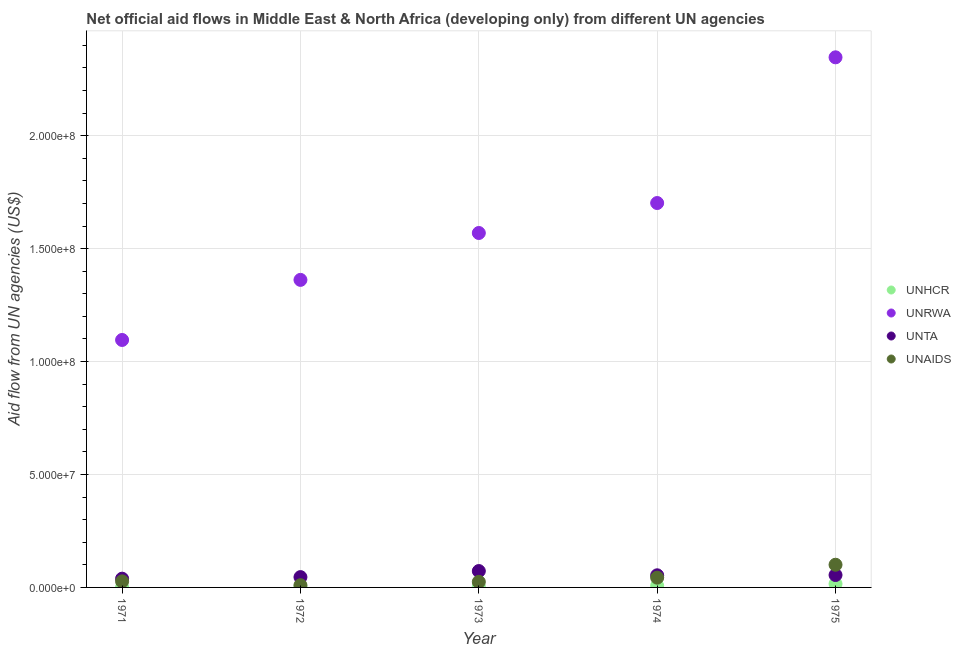How many different coloured dotlines are there?
Keep it short and to the point. 4. What is the amount of aid given by unaids in 1974?
Keep it short and to the point. 4.32e+06. Across all years, what is the maximum amount of aid given by unrwa?
Give a very brief answer. 2.35e+08. Across all years, what is the minimum amount of aid given by unhcr?
Offer a very short reply. 1.30e+05. In which year was the amount of aid given by unta maximum?
Your answer should be compact. 1973. What is the total amount of aid given by unaids in the graph?
Give a very brief answer. 2.05e+07. What is the difference between the amount of aid given by unaids in 1971 and that in 1975?
Offer a very short reply. -7.36e+06. What is the difference between the amount of aid given by unaids in 1974 and the amount of aid given by unhcr in 1973?
Your response must be concise. 3.94e+06. What is the average amount of aid given by unrwa per year?
Provide a succinct answer. 1.62e+08. In the year 1971, what is the difference between the amount of aid given by unaids and amount of aid given by unhcr?
Ensure brevity in your answer.  2.55e+06. In how many years, is the amount of aid given by unta greater than 100000000 US$?
Provide a succinct answer. 0. What is the ratio of the amount of aid given by unrwa in 1974 to that in 1975?
Make the answer very short. 0.73. Is the amount of aid given by unaids in 1971 less than that in 1975?
Provide a succinct answer. Yes. What is the difference between the highest and the second highest amount of aid given by unhcr?
Give a very brief answer. 8.30e+05. What is the difference between the highest and the lowest amount of aid given by unhcr?
Offer a very short reply. 1.45e+06. Is the sum of the amount of aid given by unrwa in 1971 and 1974 greater than the maximum amount of aid given by unaids across all years?
Make the answer very short. Yes. Is it the case that in every year, the sum of the amount of aid given by unta and amount of aid given by unhcr is greater than the sum of amount of aid given by unaids and amount of aid given by unrwa?
Your answer should be compact. Yes. Is it the case that in every year, the sum of the amount of aid given by unhcr and amount of aid given by unrwa is greater than the amount of aid given by unta?
Ensure brevity in your answer.  Yes. Does the amount of aid given by unta monotonically increase over the years?
Make the answer very short. No. Is the amount of aid given by unaids strictly greater than the amount of aid given by unta over the years?
Offer a terse response. No. How many dotlines are there?
Your response must be concise. 4. How many years are there in the graph?
Your answer should be compact. 5. Does the graph contain any zero values?
Provide a short and direct response. No. Does the graph contain grids?
Your answer should be very brief. Yes. Where does the legend appear in the graph?
Keep it short and to the point. Center right. How are the legend labels stacked?
Your answer should be very brief. Vertical. What is the title of the graph?
Offer a very short reply. Net official aid flows in Middle East & North Africa (developing only) from different UN agencies. Does "Third 20% of population" appear as one of the legend labels in the graph?
Provide a succinct answer. No. What is the label or title of the Y-axis?
Give a very brief answer. Aid flow from UN agencies (US$). What is the Aid flow from UN agencies (US$) of UNRWA in 1971?
Offer a terse response. 1.10e+08. What is the Aid flow from UN agencies (US$) in UNTA in 1971?
Provide a succinct answer. 3.88e+06. What is the Aid flow from UN agencies (US$) in UNAIDS in 1971?
Give a very brief answer. 2.68e+06. What is the Aid flow from UN agencies (US$) in UNHCR in 1972?
Offer a terse response. 2.80e+05. What is the Aid flow from UN agencies (US$) of UNRWA in 1972?
Your answer should be compact. 1.36e+08. What is the Aid flow from UN agencies (US$) in UNTA in 1972?
Ensure brevity in your answer.  4.57e+06. What is the Aid flow from UN agencies (US$) of UNAIDS in 1972?
Offer a very short reply. 9.80e+05. What is the Aid flow from UN agencies (US$) of UNRWA in 1973?
Make the answer very short. 1.57e+08. What is the Aid flow from UN agencies (US$) of UNTA in 1973?
Make the answer very short. 7.25e+06. What is the Aid flow from UN agencies (US$) in UNAIDS in 1973?
Ensure brevity in your answer.  2.47e+06. What is the Aid flow from UN agencies (US$) in UNHCR in 1974?
Make the answer very short. 7.50e+05. What is the Aid flow from UN agencies (US$) of UNRWA in 1974?
Ensure brevity in your answer.  1.70e+08. What is the Aid flow from UN agencies (US$) of UNTA in 1974?
Give a very brief answer. 5.37e+06. What is the Aid flow from UN agencies (US$) of UNAIDS in 1974?
Ensure brevity in your answer.  4.32e+06. What is the Aid flow from UN agencies (US$) in UNHCR in 1975?
Your answer should be very brief. 1.58e+06. What is the Aid flow from UN agencies (US$) in UNRWA in 1975?
Your answer should be very brief. 2.35e+08. What is the Aid flow from UN agencies (US$) in UNTA in 1975?
Your response must be concise. 5.49e+06. What is the Aid flow from UN agencies (US$) in UNAIDS in 1975?
Your response must be concise. 1.00e+07. Across all years, what is the maximum Aid flow from UN agencies (US$) in UNHCR?
Offer a terse response. 1.58e+06. Across all years, what is the maximum Aid flow from UN agencies (US$) of UNRWA?
Provide a short and direct response. 2.35e+08. Across all years, what is the maximum Aid flow from UN agencies (US$) of UNTA?
Offer a terse response. 7.25e+06. Across all years, what is the maximum Aid flow from UN agencies (US$) in UNAIDS?
Provide a succinct answer. 1.00e+07. Across all years, what is the minimum Aid flow from UN agencies (US$) of UNHCR?
Offer a terse response. 1.30e+05. Across all years, what is the minimum Aid flow from UN agencies (US$) of UNRWA?
Your response must be concise. 1.10e+08. Across all years, what is the minimum Aid flow from UN agencies (US$) in UNTA?
Keep it short and to the point. 3.88e+06. Across all years, what is the minimum Aid flow from UN agencies (US$) of UNAIDS?
Provide a succinct answer. 9.80e+05. What is the total Aid flow from UN agencies (US$) in UNHCR in the graph?
Provide a short and direct response. 3.12e+06. What is the total Aid flow from UN agencies (US$) in UNRWA in the graph?
Ensure brevity in your answer.  8.08e+08. What is the total Aid flow from UN agencies (US$) in UNTA in the graph?
Your response must be concise. 2.66e+07. What is the total Aid flow from UN agencies (US$) of UNAIDS in the graph?
Ensure brevity in your answer.  2.05e+07. What is the difference between the Aid flow from UN agencies (US$) in UNHCR in 1971 and that in 1972?
Ensure brevity in your answer.  -1.50e+05. What is the difference between the Aid flow from UN agencies (US$) of UNRWA in 1971 and that in 1972?
Ensure brevity in your answer.  -2.66e+07. What is the difference between the Aid flow from UN agencies (US$) in UNTA in 1971 and that in 1972?
Keep it short and to the point. -6.90e+05. What is the difference between the Aid flow from UN agencies (US$) in UNAIDS in 1971 and that in 1972?
Your answer should be compact. 1.70e+06. What is the difference between the Aid flow from UN agencies (US$) of UNRWA in 1971 and that in 1973?
Make the answer very short. -4.74e+07. What is the difference between the Aid flow from UN agencies (US$) of UNTA in 1971 and that in 1973?
Your answer should be very brief. -3.37e+06. What is the difference between the Aid flow from UN agencies (US$) in UNAIDS in 1971 and that in 1973?
Offer a very short reply. 2.10e+05. What is the difference between the Aid flow from UN agencies (US$) in UNHCR in 1971 and that in 1974?
Offer a very short reply. -6.20e+05. What is the difference between the Aid flow from UN agencies (US$) in UNRWA in 1971 and that in 1974?
Give a very brief answer. -6.06e+07. What is the difference between the Aid flow from UN agencies (US$) in UNTA in 1971 and that in 1974?
Give a very brief answer. -1.49e+06. What is the difference between the Aid flow from UN agencies (US$) of UNAIDS in 1971 and that in 1974?
Give a very brief answer. -1.64e+06. What is the difference between the Aid flow from UN agencies (US$) in UNHCR in 1971 and that in 1975?
Your answer should be compact. -1.45e+06. What is the difference between the Aid flow from UN agencies (US$) of UNRWA in 1971 and that in 1975?
Ensure brevity in your answer.  -1.25e+08. What is the difference between the Aid flow from UN agencies (US$) in UNTA in 1971 and that in 1975?
Offer a very short reply. -1.61e+06. What is the difference between the Aid flow from UN agencies (US$) of UNAIDS in 1971 and that in 1975?
Provide a succinct answer. -7.36e+06. What is the difference between the Aid flow from UN agencies (US$) of UNHCR in 1972 and that in 1973?
Your answer should be compact. -1.00e+05. What is the difference between the Aid flow from UN agencies (US$) of UNRWA in 1972 and that in 1973?
Give a very brief answer. -2.08e+07. What is the difference between the Aid flow from UN agencies (US$) of UNTA in 1972 and that in 1973?
Ensure brevity in your answer.  -2.68e+06. What is the difference between the Aid flow from UN agencies (US$) of UNAIDS in 1972 and that in 1973?
Offer a very short reply. -1.49e+06. What is the difference between the Aid flow from UN agencies (US$) of UNHCR in 1972 and that in 1974?
Offer a terse response. -4.70e+05. What is the difference between the Aid flow from UN agencies (US$) in UNRWA in 1972 and that in 1974?
Your answer should be very brief. -3.40e+07. What is the difference between the Aid flow from UN agencies (US$) in UNTA in 1972 and that in 1974?
Keep it short and to the point. -8.00e+05. What is the difference between the Aid flow from UN agencies (US$) in UNAIDS in 1972 and that in 1974?
Give a very brief answer. -3.34e+06. What is the difference between the Aid flow from UN agencies (US$) of UNHCR in 1972 and that in 1975?
Ensure brevity in your answer.  -1.30e+06. What is the difference between the Aid flow from UN agencies (US$) in UNRWA in 1972 and that in 1975?
Ensure brevity in your answer.  -9.85e+07. What is the difference between the Aid flow from UN agencies (US$) in UNTA in 1972 and that in 1975?
Make the answer very short. -9.20e+05. What is the difference between the Aid flow from UN agencies (US$) in UNAIDS in 1972 and that in 1975?
Your answer should be compact. -9.06e+06. What is the difference between the Aid flow from UN agencies (US$) in UNHCR in 1973 and that in 1974?
Keep it short and to the point. -3.70e+05. What is the difference between the Aid flow from UN agencies (US$) of UNRWA in 1973 and that in 1974?
Your answer should be compact. -1.33e+07. What is the difference between the Aid flow from UN agencies (US$) of UNTA in 1973 and that in 1974?
Give a very brief answer. 1.88e+06. What is the difference between the Aid flow from UN agencies (US$) of UNAIDS in 1973 and that in 1974?
Offer a very short reply. -1.85e+06. What is the difference between the Aid flow from UN agencies (US$) in UNHCR in 1973 and that in 1975?
Offer a very short reply. -1.20e+06. What is the difference between the Aid flow from UN agencies (US$) of UNRWA in 1973 and that in 1975?
Offer a very short reply. -7.78e+07. What is the difference between the Aid flow from UN agencies (US$) in UNTA in 1973 and that in 1975?
Your answer should be compact. 1.76e+06. What is the difference between the Aid flow from UN agencies (US$) in UNAIDS in 1973 and that in 1975?
Your response must be concise. -7.57e+06. What is the difference between the Aid flow from UN agencies (US$) of UNHCR in 1974 and that in 1975?
Offer a terse response. -8.30e+05. What is the difference between the Aid flow from UN agencies (US$) in UNRWA in 1974 and that in 1975?
Ensure brevity in your answer.  -6.45e+07. What is the difference between the Aid flow from UN agencies (US$) in UNAIDS in 1974 and that in 1975?
Make the answer very short. -5.72e+06. What is the difference between the Aid flow from UN agencies (US$) of UNHCR in 1971 and the Aid flow from UN agencies (US$) of UNRWA in 1972?
Provide a short and direct response. -1.36e+08. What is the difference between the Aid flow from UN agencies (US$) of UNHCR in 1971 and the Aid flow from UN agencies (US$) of UNTA in 1972?
Ensure brevity in your answer.  -4.44e+06. What is the difference between the Aid flow from UN agencies (US$) of UNHCR in 1971 and the Aid flow from UN agencies (US$) of UNAIDS in 1972?
Keep it short and to the point. -8.50e+05. What is the difference between the Aid flow from UN agencies (US$) of UNRWA in 1971 and the Aid flow from UN agencies (US$) of UNTA in 1972?
Offer a very short reply. 1.05e+08. What is the difference between the Aid flow from UN agencies (US$) of UNRWA in 1971 and the Aid flow from UN agencies (US$) of UNAIDS in 1972?
Your response must be concise. 1.09e+08. What is the difference between the Aid flow from UN agencies (US$) of UNTA in 1971 and the Aid flow from UN agencies (US$) of UNAIDS in 1972?
Your answer should be very brief. 2.90e+06. What is the difference between the Aid flow from UN agencies (US$) of UNHCR in 1971 and the Aid flow from UN agencies (US$) of UNRWA in 1973?
Your answer should be compact. -1.57e+08. What is the difference between the Aid flow from UN agencies (US$) of UNHCR in 1971 and the Aid flow from UN agencies (US$) of UNTA in 1973?
Keep it short and to the point. -7.12e+06. What is the difference between the Aid flow from UN agencies (US$) in UNHCR in 1971 and the Aid flow from UN agencies (US$) in UNAIDS in 1973?
Offer a terse response. -2.34e+06. What is the difference between the Aid flow from UN agencies (US$) in UNRWA in 1971 and the Aid flow from UN agencies (US$) in UNTA in 1973?
Offer a terse response. 1.02e+08. What is the difference between the Aid flow from UN agencies (US$) in UNRWA in 1971 and the Aid flow from UN agencies (US$) in UNAIDS in 1973?
Ensure brevity in your answer.  1.07e+08. What is the difference between the Aid flow from UN agencies (US$) in UNTA in 1971 and the Aid flow from UN agencies (US$) in UNAIDS in 1973?
Offer a very short reply. 1.41e+06. What is the difference between the Aid flow from UN agencies (US$) of UNHCR in 1971 and the Aid flow from UN agencies (US$) of UNRWA in 1974?
Your response must be concise. -1.70e+08. What is the difference between the Aid flow from UN agencies (US$) of UNHCR in 1971 and the Aid flow from UN agencies (US$) of UNTA in 1974?
Make the answer very short. -5.24e+06. What is the difference between the Aid flow from UN agencies (US$) in UNHCR in 1971 and the Aid flow from UN agencies (US$) in UNAIDS in 1974?
Make the answer very short. -4.19e+06. What is the difference between the Aid flow from UN agencies (US$) of UNRWA in 1971 and the Aid flow from UN agencies (US$) of UNTA in 1974?
Your answer should be compact. 1.04e+08. What is the difference between the Aid flow from UN agencies (US$) in UNRWA in 1971 and the Aid flow from UN agencies (US$) in UNAIDS in 1974?
Keep it short and to the point. 1.05e+08. What is the difference between the Aid flow from UN agencies (US$) in UNTA in 1971 and the Aid flow from UN agencies (US$) in UNAIDS in 1974?
Provide a short and direct response. -4.40e+05. What is the difference between the Aid flow from UN agencies (US$) of UNHCR in 1971 and the Aid flow from UN agencies (US$) of UNRWA in 1975?
Give a very brief answer. -2.35e+08. What is the difference between the Aid flow from UN agencies (US$) of UNHCR in 1971 and the Aid flow from UN agencies (US$) of UNTA in 1975?
Your response must be concise. -5.36e+06. What is the difference between the Aid flow from UN agencies (US$) in UNHCR in 1971 and the Aid flow from UN agencies (US$) in UNAIDS in 1975?
Your answer should be very brief. -9.91e+06. What is the difference between the Aid flow from UN agencies (US$) in UNRWA in 1971 and the Aid flow from UN agencies (US$) in UNTA in 1975?
Offer a very short reply. 1.04e+08. What is the difference between the Aid flow from UN agencies (US$) of UNRWA in 1971 and the Aid flow from UN agencies (US$) of UNAIDS in 1975?
Your answer should be very brief. 9.95e+07. What is the difference between the Aid flow from UN agencies (US$) in UNTA in 1971 and the Aid flow from UN agencies (US$) in UNAIDS in 1975?
Provide a short and direct response. -6.16e+06. What is the difference between the Aid flow from UN agencies (US$) of UNHCR in 1972 and the Aid flow from UN agencies (US$) of UNRWA in 1973?
Ensure brevity in your answer.  -1.57e+08. What is the difference between the Aid flow from UN agencies (US$) in UNHCR in 1972 and the Aid flow from UN agencies (US$) in UNTA in 1973?
Your response must be concise. -6.97e+06. What is the difference between the Aid flow from UN agencies (US$) in UNHCR in 1972 and the Aid flow from UN agencies (US$) in UNAIDS in 1973?
Your response must be concise. -2.19e+06. What is the difference between the Aid flow from UN agencies (US$) in UNRWA in 1972 and the Aid flow from UN agencies (US$) in UNTA in 1973?
Provide a short and direct response. 1.29e+08. What is the difference between the Aid flow from UN agencies (US$) of UNRWA in 1972 and the Aid flow from UN agencies (US$) of UNAIDS in 1973?
Your response must be concise. 1.34e+08. What is the difference between the Aid flow from UN agencies (US$) of UNTA in 1972 and the Aid flow from UN agencies (US$) of UNAIDS in 1973?
Your response must be concise. 2.10e+06. What is the difference between the Aid flow from UN agencies (US$) of UNHCR in 1972 and the Aid flow from UN agencies (US$) of UNRWA in 1974?
Offer a terse response. -1.70e+08. What is the difference between the Aid flow from UN agencies (US$) of UNHCR in 1972 and the Aid flow from UN agencies (US$) of UNTA in 1974?
Make the answer very short. -5.09e+06. What is the difference between the Aid flow from UN agencies (US$) of UNHCR in 1972 and the Aid flow from UN agencies (US$) of UNAIDS in 1974?
Offer a terse response. -4.04e+06. What is the difference between the Aid flow from UN agencies (US$) of UNRWA in 1972 and the Aid flow from UN agencies (US$) of UNTA in 1974?
Provide a succinct answer. 1.31e+08. What is the difference between the Aid flow from UN agencies (US$) in UNRWA in 1972 and the Aid flow from UN agencies (US$) in UNAIDS in 1974?
Your answer should be compact. 1.32e+08. What is the difference between the Aid flow from UN agencies (US$) of UNHCR in 1972 and the Aid flow from UN agencies (US$) of UNRWA in 1975?
Give a very brief answer. -2.34e+08. What is the difference between the Aid flow from UN agencies (US$) in UNHCR in 1972 and the Aid flow from UN agencies (US$) in UNTA in 1975?
Ensure brevity in your answer.  -5.21e+06. What is the difference between the Aid flow from UN agencies (US$) of UNHCR in 1972 and the Aid flow from UN agencies (US$) of UNAIDS in 1975?
Your response must be concise. -9.76e+06. What is the difference between the Aid flow from UN agencies (US$) of UNRWA in 1972 and the Aid flow from UN agencies (US$) of UNTA in 1975?
Keep it short and to the point. 1.31e+08. What is the difference between the Aid flow from UN agencies (US$) of UNRWA in 1972 and the Aid flow from UN agencies (US$) of UNAIDS in 1975?
Ensure brevity in your answer.  1.26e+08. What is the difference between the Aid flow from UN agencies (US$) of UNTA in 1972 and the Aid flow from UN agencies (US$) of UNAIDS in 1975?
Make the answer very short. -5.47e+06. What is the difference between the Aid flow from UN agencies (US$) in UNHCR in 1973 and the Aid flow from UN agencies (US$) in UNRWA in 1974?
Give a very brief answer. -1.70e+08. What is the difference between the Aid flow from UN agencies (US$) in UNHCR in 1973 and the Aid flow from UN agencies (US$) in UNTA in 1974?
Give a very brief answer. -4.99e+06. What is the difference between the Aid flow from UN agencies (US$) in UNHCR in 1973 and the Aid flow from UN agencies (US$) in UNAIDS in 1974?
Offer a terse response. -3.94e+06. What is the difference between the Aid flow from UN agencies (US$) in UNRWA in 1973 and the Aid flow from UN agencies (US$) in UNTA in 1974?
Provide a short and direct response. 1.52e+08. What is the difference between the Aid flow from UN agencies (US$) of UNRWA in 1973 and the Aid flow from UN agencies (US$) of UNAIDS in 1974?
Your answer should be compact. 1.53e+08. What is the difference between the Aid flow from UN agencies (US$) in UNTA in 1973 and the Aid flow from UN agencies (US$) in UNAIDS in 1974?
Keep it short and to the point. 2.93e+06. What is the difference between the Aid flow from UN agencies (US$) of UNHCR in 1973 and the Aid flow from UN agencies (US$) of UNRWA in 1975?
Provide a short and direct response. -2.34e+08. What is the difference between the Aid flow from UN agencies (US$) of UNHCR in 1973 and the Aid flow from UN agencies (US$) of UNTA in 1975?
Keep it short and to the point. -5.11e+06. What is the difference between the Aid flow from UN agencies (US$) of UNHCR in 1973 and the Aid flow from UN agencies (US$) of UNAIDS in 1975?
Give a very brief answer. -9.66e+06. What is the difference between the Aid flow from UN agencies (US$) of UNRWA in 1973 and the Aid flow from UN agencies (US$) of UNTA in 1975?
Keep it short and to the point. 1.51e+08. What is the difference between the Aid flow from UN agencies (US$) of UNRWA in 1973 and the Aid flow from UN agencies (US$) of UNAIDS in 1975?
Provide a short and direct response. 1.47e+08. What is the difference between the Aid flow from UN agencies (US$) in UNTA in 1973 and the Aid flow from UN agencies (US$) in UNAIDS in 1975?
Make the answer very short. -2.79e+06. What is the difference between the Aid flow from UN agencies (US$) of UNHCR in 1974 and the Aid flow from UN agencies (US$) of UNRWA in 1975?
Provide a short and direct response. -2.34e+08. What is the difference between the Aid flow from UN agencies (US$) in UNHCR in 1974 and the Aid flow from UN agencies (US$) in UNTA in 1975?
Make the answer very short. -4.74e+06. What is the difference between the Aid flow from UN agencies (US$) in UNHCR in 1974 and the Aid flow from UN agencies (US$) in UNAIDS in 1975?
Offer a terse response. -9.29e+06. What is the difference between the Aid flow from UN agencies (US$) of UNRWA in 1974 and the Aid flow from UN agencies (US$) of UNTA in 1975?
Your answer should be compact. 1.65e+08. What is the difference between the Aid flow from UN agencies (US$) of UNRWA in 1974 and the Aid flow from UN agencies (US$) of UNAIDS in 1975?
Your response must be concise. 1.60e+08. What is the difference between the Aid flow from UN agencies (US$) of UNTA in 1974 and the Aid flow from UN agencies (US$) of UNAIDS in 1975?
Make the answer very short. -4.67e+06. What is the average Aid flow from UN agencies (US$) in UNHCR per year?
Provide a short and direct response. 6.24e+05. What is the average Aid flow from UN agencies (US$) in UNRWA per year?
Provide a succinct answer. 1.62e+08. What is the average Aid flow from UN agencies (US$) of UNTA per year?
Your response must be concise. 5.31e+06. What is the average Aid flow from UN agencies (US$) of UNAIDS per year?
Provide a short and direct response. 4.10e+06. In the year 1971, what is the difference between the Aid flow from UN agencies (US$) of UNHCR and Aid flow from UN agencies (US$) of UNRWA?
Your response must be concise. -1.09e+08. In the year 1971, what is the difference between the Aid flow from UN agencies (US$) in UNHCR and Aid flow from UN agencies (US$) in UNTA?
Give a very brief answer. -3.75e+06. In the year 1971, what is the difference between the Aid flow from UN agencies (US$) of UNHCR and Aid flow from UN agencies (US$) of UNAIDS?
Make the answer very short. -2.55e+06. In the year 1971, what is the difference between the Aid flow from UN agencies (US$) of UNRWA and Aid flow from UN agencies (US$) of UNTA?
Your answer should be very brief. 1.06e+08. In the year 1971, what is the difference between the Aid flow from UN agencies (US$) of UNRWA and Aid flow from UN agencies (US$) of UNAIDS?
Keep it short and to the point. 1.07e+08. In the year 1971, what is the difference between the Aid flow from UN agencies (US$) of UNTA and Aid flow from UN agencies (US$) of UNAIDS?
Offer a very short reply. 1.20e+06. In the year 1972, what is the difference between the Aid flow from UN agencies (US$) of UNHCR and Aid flow from UN agencies (US$) of UNRWA?
Keep it short and to the point. -1.36e+08. In the year 1972, what is the difference between the Aid flow from UN agencies (US$) in UNHCR and Aid flow from UN agencies (US$) in UNTA?
Your answer should be very brief. -4.29e+06. In the year 1972, what is the difference between the Aid flow from UN agencies (US$) in UNHCR and Aid flow from UN agencies (US$) in UNAIDS?
Keep it short and to the point. -7.00e+05. In the year 1972, what is the difference between the Aid flow from UN agencies (US$) of UNRWA and Aid flow from UN agencies (US$) of UNTA?
Give a very brief answer. 1.32e+08. In the year 1972, what is the difference between the Aid flow from UN agencies (US$) of UNRWA and Aid flow from UN agencies (US$) of UNAIDS?
Provide a short and direct response. 1.35e+08. In the year 1972, what is the difference between the Aid flow from UN agencies (US$) in UNTA and Aid flow from UN agencies (US$) in UNAIDS?
Make the answer very short. 3.59e+06. In the year 1973, what is the difference between the Aid flow from UN agencies (US$) of UNHCR and Aid flow from UN agencies (US$) of UNRWA?
Offer a very short reply. -1.57e+08. In the year 1973, what is the difference between the Aid flow from UN agencies (US$) in UNHCR and Aid flow from UN agencies (US$) in UNTA?
Give a very brief answer. -6.87e+06. In the year 1973, what is the difference between the Aid flow from UN agencies (US$) in UNHCR and Aid flow from UN agencies (US$) in UNAIDS?
Offer a terse response. -2.09e+06. In the year 1973, what is the difference between the Aid flow from UN agencies (US$) in UNRWA and Aid flow from UN agencies (US$) in UNTA?
Keep it short and to the point. 1.50e+08. In the year 1973, what is the difference between the Aid flow from UN agencies (US$) of UNRWA and Aid flow from UN agencies (US$) of UNAIDS?
Provide a succinct answer. 1.54e+08. In the year 1973, what is the difference between the Aid flow from UN agencies (US$) of UNTA and Aid flow from UN agencies (US$) of UNAIDS?
Ensure brevity in your answer.  4.78e+06. In the year 1974, what is the difference between the Aid flow from UN agencies (US$) in UNHCR and Aid flow from UN agencies (US$) in UNRWA?
Your response must be concise. -1.69e+08. In the year 1974, what is the difference between the Aid flow from UN agencies (US$) of UNHCR and Aid flow from UN agencies (US$) of UNTA?
Ensure brevity in your answer.  -4.62e+06. In the year 1974, what is the difference between the Aid flow from UN agencies (US$) in UNHCR and Aid flow from UN agencies (US$) in UNAIDS?
Give a very brief answer. -3.57e+06. In the year 1974, what is the difference between the Aid flow from UN agencies (US$) in UNRWA and Aid flow from UN agencies (US$) in UNTA?
Provide a succinct answer. 1.65e+08. In the year 1974, what is the difference between the Aid flow from UN agencies (US$) of UNRWA and Aid flow from UN agencies (US$) of UNAIDS?
Give a very brief answer. 1.66e+08. In the year 1974, what is the difference between the Aid flow from UN agencies (US$) in UNTA and Aid flow from UN agencies (US$) in UNAIDS?
Your answer should be very brief. 1.05e+06. In the year 1975, what is the difference between the Aid flow from UN agencies (US$) of UNHCR and Aid flow from UN agencies (US$) of UNRWA?
Your response must be concise. -2.33e+08. In the year 1975, what is the difference between the Aid flow from UN agencies (US$) of UNHCR and Aid flow from UN agencies (US$) of UNTA?
Your response must be concise. -3.91e+06. In the year 1975, what is the difference between the Aid flow from UN agencies (US$) in UNHCR and Aid flow from UN agencies (US$) in UNAIDS?
Offer a very short reply. -8.46e+06. In the year 1975, what is the difference between the Aid flow from UN agencies (US$) of UNRWA and Aid flow from UN agencies (US$) of UNTA?
Your answer should be compact. 2.29e+08. In the year 1975, what is the difference between the Aid flow from UN agencies (US$) of UNRWA and Aid flow from UN agencies (US$) of UNAIDS?
Make the answer very short. 2.25e+08. In the year 1975, what is the difference between the Aid flow from UN agencies (US$) in UNTA and Aid flow from UN agencies (US$) in UNAIDS?
Your answer should be compact. -4.55e+06. What is the ratio of the Aid flow from UN agencies (US$) in UNHCR in 1971 to that in 1972?
Offer a terse response. 0.46. What is the ratio of the Aid flow from UN agencies (US$) of UNRWA in 1971 to that in 1972?
Your response must be concise. 0.8. What is the ratio of the Aid flow from UN agencies (US$) of UNTA in 1971 to that in 1972?
Make the answer very short. 0.85. What is the ratio of the Aid flow from UN agencies (US$) of UNAIDS in 1971 to that in 1972?
Ensure brevity in your answer.  2.73. What is the ratio of the Aid flow from UN agencies (US$) of UNHCR in 1971 to that in 1973?
Provide a short and direct response. 0.34. What is the ratio of the Aid flow from UN agencies (US$) of UNRWA in 1971 to that in 1973?
Offer a very short reply. 0.7. What is the ratio of the Aid flow from UN agencies (US$) in UNTA in 1971 to that in 1973?
Offer a terse response. 0.54. What is the ratio of the Aid flow from UN agencies (US$) of UNAIDS in 1971 to that in 1973?
Offer a terse response. 1.08. What is the ratio of the Aid flow from UN agencies (US$) of UNHCR in 1971 to that in 1974?
Your answer should be compact. 0.17. What is the ratio of the Aid flow from UN agencies (US$) of UNRWA in 1971 to that in 1974?
Give a very brief answer. 0.64. What is the ratio of the Aid flow from UN agencies (US$) in UNTA in 1971 to that in 1974?
Offer a very short reply. 0.72. What is the ratio of the Aid flow from UN agencies (US$) of UNAIDS in 1971 to that in 1974?
Give a very brief answer. 0.62. What is the ratio of the Aid flow from UN agencies (US$) of UNHCR in 1971 to that in 1975?
Give a very brief answer. 0.08. What is the ratio of the Aid flow from UN agencies (US$) in UNRWA in 1971 to that in 1975?
Provide a short and direct response. 0.47. What is the ratio of the Aid flow from UN agencies (US$) of UNTA in 1971 to that in 1975?
Make the answer very short. 0.71. What is the ratio of the Aid flow from UN agencies (US$) of UNAIDS in 1971 to that in 1975?
Offer a terse response. 0.27. What is the ratio of the Aid flow from UN agencies (US$) in UNHCR in 1972 to that in 1973?
Provide a succinct answer. 0.74. What is the ratio of the Aid flow from UN agencies (US$) in UNRWA in 1972 to that in 1973?
Provide a short and direct response. 0.87. What is the ratio of the Aid flow from UN agencies (US$) of UNTA in 1972 to that in 1973?
Ensure brevity in your answer.  0.63. What is the ratio of the Aid flow from UN agencies (US$) of UNAIDS in 1972 to that in 1973?
Keep it short and to the point. 0.4. What is the ratio of the Aid flow from UN agencies (US$) in UNHCR in 1972 to that in 1974?
Offer a terse response. 0.37. What is the ratio of the Aid flow from UN agencies (US$) in UNRWA in 1972 to that in 1974?
Provide a short and direct response. 0.8. What is the ratio of the Aid flow from UN agencies (US$) of UNTA in 1972 to that in 1974?
Your response must be concise. 0.85. What is the ratio of the Aid flow from UN agencies (US$) in UNAIDS in 1972 to that in 1974?
Keep it short and to the point. 0.23. What is the ratio of the Aid flow from UN agencies (US$) in UNHCR in 1972 to that in 1975?
Ensure brevity in your answer.  0.18. What is the ratio of the Aid flow from UN agencies (US$) in UNRWA in 1972 to that in 1975?
Give a very brief answer. 0.58. What is the ratio of the Aid flow from UN agencies (US$) of UNTA in 1972 to that in 1975?
Make the answer very short. 0.83. What is the ratio of the Aid flow from UN agencies (US$) in UNAIDS in 1972 to that in 1975?
Your answer should be very brief. 0.1. What is the ratio of the Aid flow from UN agencies (US$) in UNHCR in 1973 to that in 1974?
Provide a short and direct response. 0.51. What is the ratio of the Aid flow from UN agencies (US$) in UNRWA in 1973 to that in 1974?
Ensure brevity in your answer.  0.92. What is the ratio of the Aid flow from UN agencies (US$) in UNTA in 1973 to that in 1974?
Ensure brevity in your answer.  1.35. What is the ratio of the Aid flow from UN agencies (US$) of UNAIDS in 1973 to that in 1974?
Keep it short and to the point. 0.57. What is the ratio of the Aid flow from UN agencies (US$) of UNHCR in 1973 to that in 1975?
Offer a very short reply. 0.24. What is the ratio of the Aid flow from UN agencies (US$) in UNRWA in 1973 to that in 1975?
Make the answer very short. 0.67. What is the ratio of the Aid flow from UN agencies (US$) in UNTA in 1973 to that in 1975?
Your answer should be very brief. 1.32. What is the ratio of the Aid flow from UN agencies (US$) in UNAIDS in 1973 to that in 1975?
Offer a very short reply. 0.25. What is the ratio of the Aid flow from UN agencies (US$) in UNHCR in 1974 to that in 1975?
Your answer should be very brief. 0.47. What is the ratio of the Aid flow from UN agencies (US$) of UNRWA in 1974 to that in 1975?
Your answer should be compact. 0.73. What is the ratio of the Aid flow from UN agencies (US$) of UNTA in 1974 to that in 1975?
Ensure brevity in your answer.  0.98. What is the ratio of the Aid flow from UN agencies (US$) of UNAIDS in 1974 to that in 1975?
Offer a very short reply. 0.43. What is the difference between the highest and the second highest Aid flow from UN agencies (US$) of UNHCR?
Your response must be concise. 8.30e+05. What is the difference between the highest and the second highest Aid flow from UN agencies (US$) in UNRWA?
Your answer should be very brief. 6.45e+07. What is the difference between the highest and the second highest Aid flow from UN agencies (US$) of UNTA?
Offer a very short reply. 1.76e+06. What is the difference between the highest and the second highest Aid flow from UN agencies (US$) in UNAIDS?
Give a very brief answer. 5.72e+06. What is the difference between the highest and the lowest Aid flow from UN agencies (US$) in UNHCR?
Your response must be concise. 1.45e+06. What is the difference between the highest and the lowest Aid flow from UN agencies (US$) of UNRWA?
Provide a short and direct response. 1.25e+08. What is the difference between the highest and the lowest Aid flow from UN agencies (US$) of UNTA?
Provide a short and direct response. 3.37e+06. What is the difference between the highest and the lowest Aid flow from UN agencies (US$) of UNAIDS?
Your answer should be very brief. 9.06e+06. 